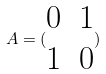<formula> <loc_0><loc_0><loc_500><loc_500>A = ( \begin{matrix} 0 & 1 \\ 1 & 0 \end{matrix} )</formula> 